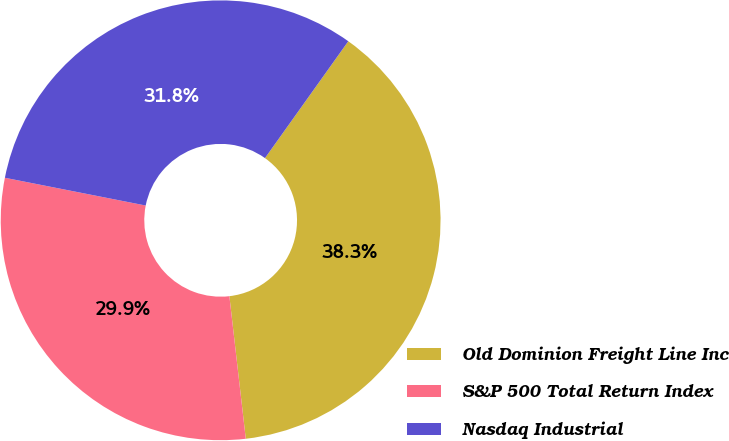<chart> <loc_0><loc_0><loc_500><loc_500><pie_chart><fcel>Old Dominion Freight Line Inc<fcel>S&P 500 Total Return Index<fcel>Nasdaq Industrial<nl><fcel>38.32%<fcel>29.92%<fcel>31.76%<nl></chart> 